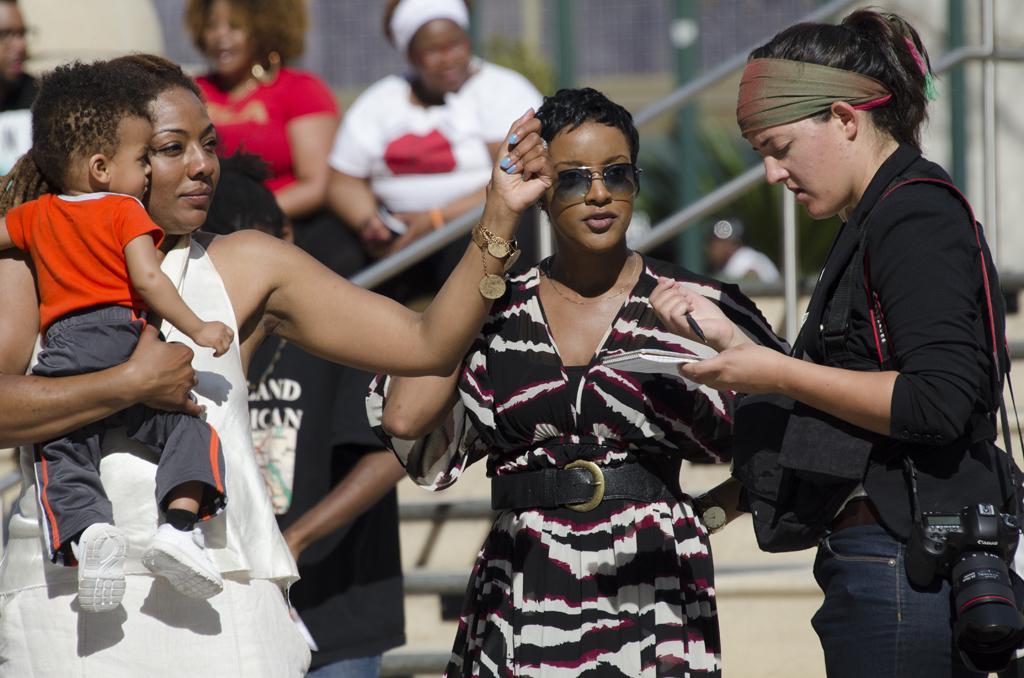Could you give a brief overview of what you see in this image? In this picture we can see a group of people, camera, rods and in the background it is blurry. 